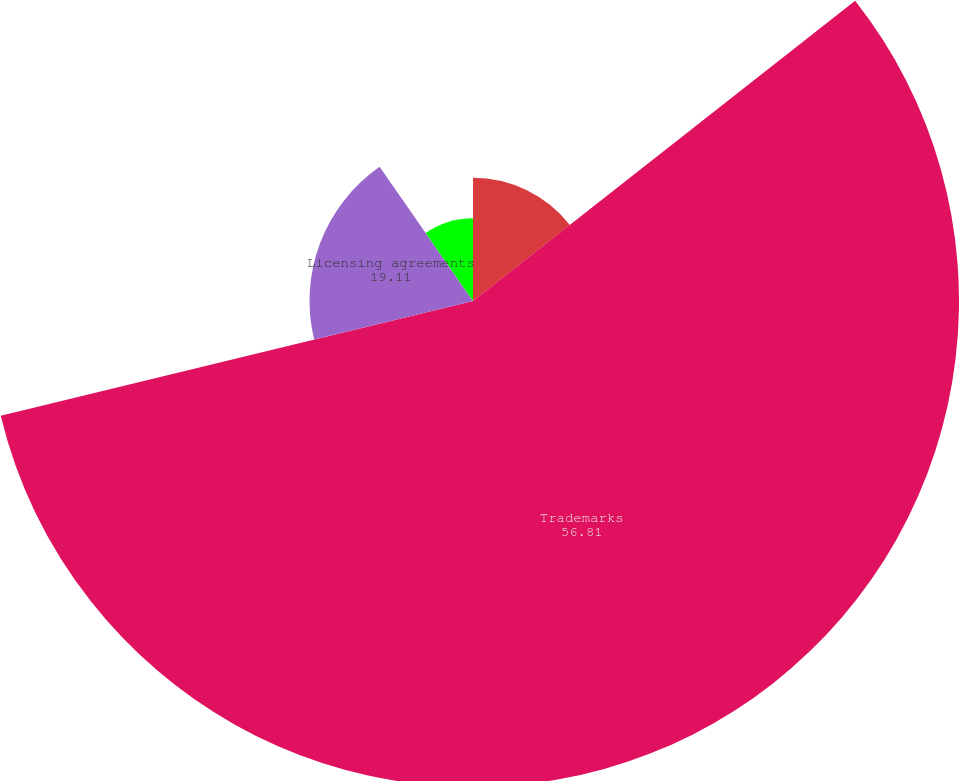<chart> <loc_0><loc_0><loc_500><loc_500><pie_chart><fcel>Patents<fcel>Trademarks<fcel>Licensing agreements<fcel>Other<nl><fcel>14.4%<fcel>56.81%<fcel>19.11%<fcel>9.68%<nl></chart> 